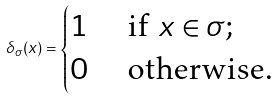Convert formula to latex. <formula><loc_0><loc_0><loc_500><loc_500>\delta _ { \sigma } ( x ) = \begin{cases} 1 & \text { if } x \in \sigma ; \\ 0 & \text { otherwise.} \end{cases}</formula> 